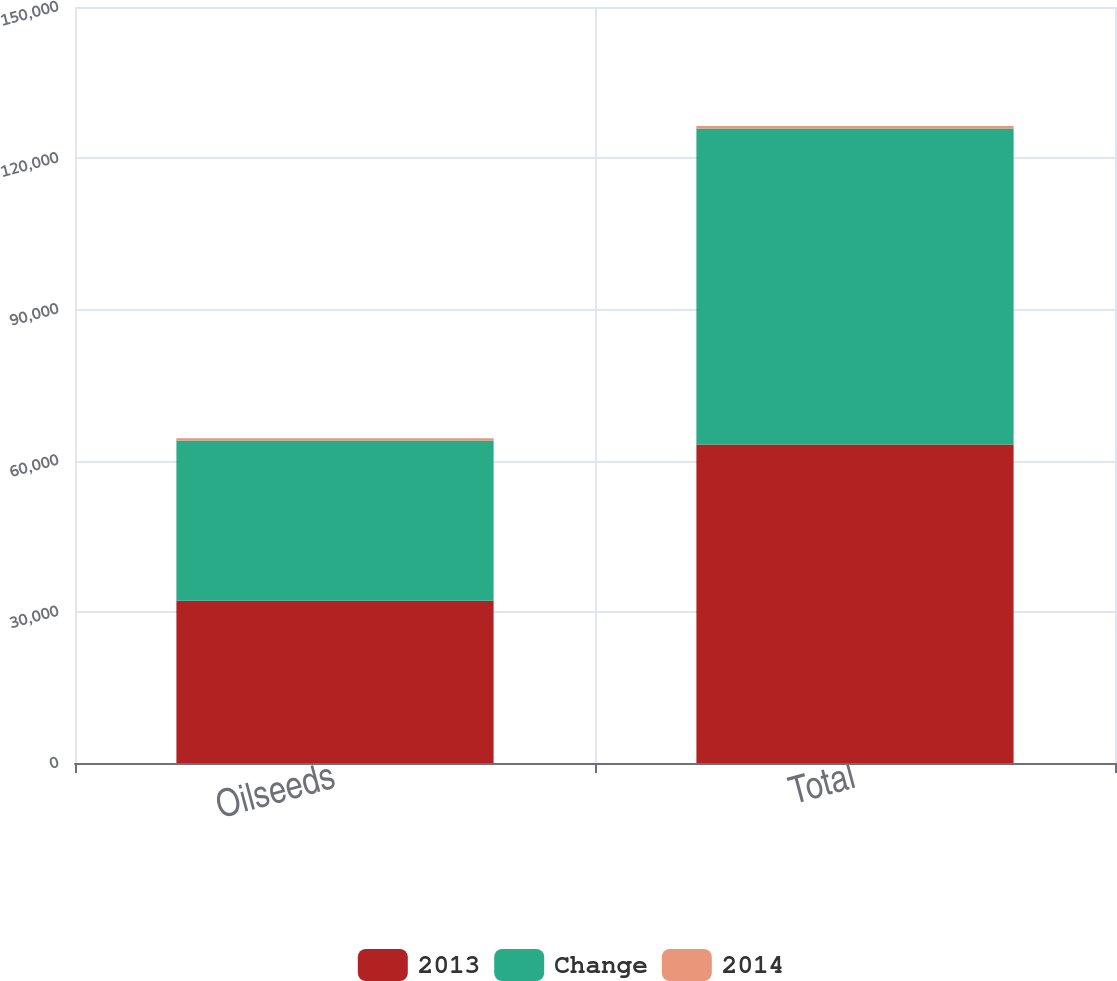Convert chart to OTSL. <chart><loc_0><loc_0><loc_500><loc_500><stacked_bar_chart><ecel><fcel>Oilseeds<fcel>Total<nl><fcel>2013<fcel>32208<fcel>63194<nl><fcel>Change<fcel>31768<fcel>62682<nl><fcel>2014<fcel>440<fcel>512<nl></chart> 